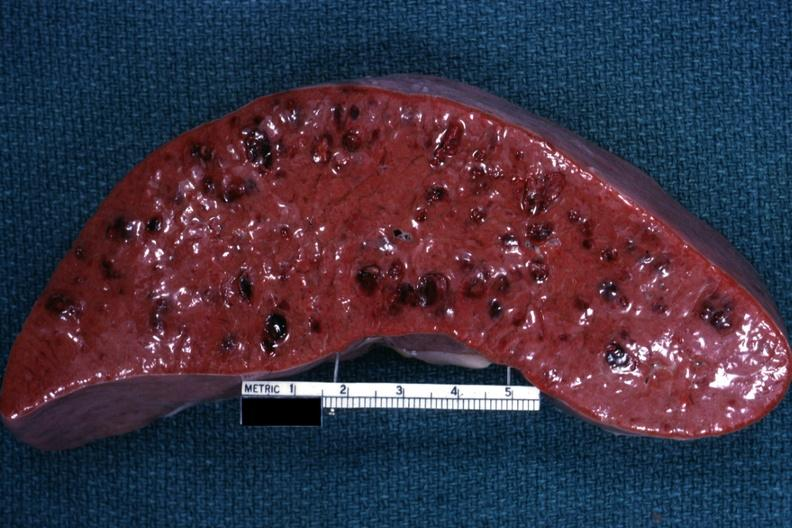s pierre robin sndrome present?
Answer the question using a single word or phrase. No 